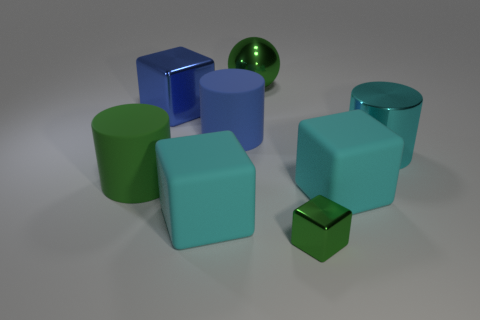Add 1 tiny green blocks. How many objects exist? 9 Subtract all balls. How many objects are left? 7 Subtract all cyan shiny things. Subtract all tiny things. How many objects are left? 6 Add 6 cyan cubes. How many cyan cubes are left? 8 Add 2 cyan shiny cubes. How many cyan shiny cubes exist? 2 Subtract 0 cyan spheres. How many objects are left? 8 